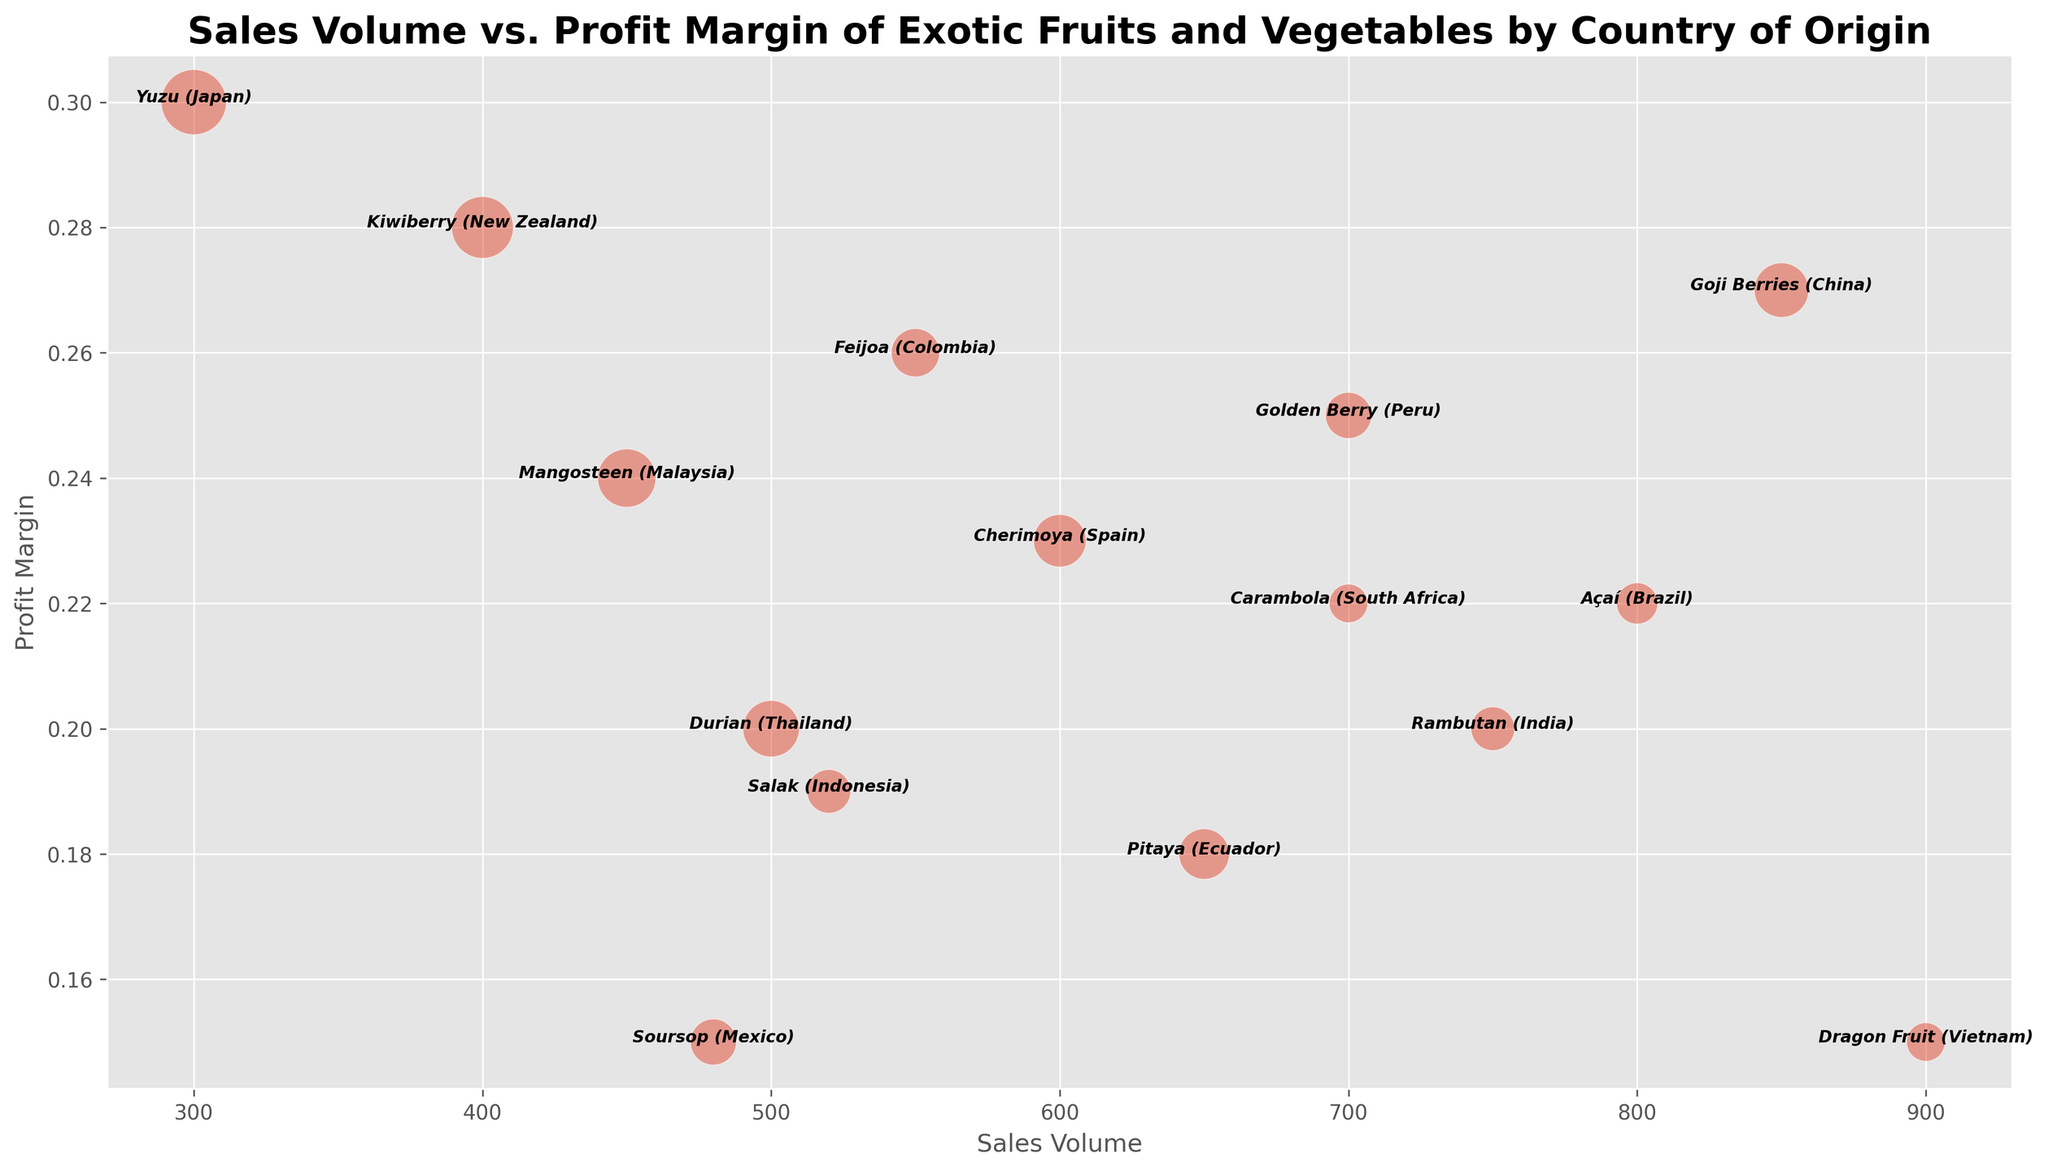What's the country with the highest profit margin for its produce? Look for the bubble situated highest on the profit margin (vertical) axis. The highest point corresponds to Yuzu from Japan with a profit margin of 0.30.
Answer: Japan Which exotic produce has the largest sales volume? Look for the bubble farthest to the right, indicating the highest value on the sales volume (horizontal) axis. Dragon Fruit from Vietnam has the highest sales volume at 900 units.
Answer: Dragon Fruit Which country offers produce with a profit margin less than 0.20 and a sales volume more than 500? Identify bubbles below the 0.20 profit margin line and to the right of the 500 sales volume line. Dragon Fruit from Vietnam (profit margin 0.15) is the answer.
Answer: Vietnam What are the top three countries in terms of sales volume? Sort bubbles by their position on the sales volume (horizontal) axis. The top three bubbles are Dragon Fruit (Vietnam, 900), Goji Berries (China, 850), and Açaí (Brazil, 800).
Answer: Vietnam, China, Brazil How does the profit margin of Rambutan compare to that of Pitaya? Find the bubbles for Rambutan and Pitaya and compare their positions on the profit margin axis. Rambutan has a profit margin of 0.20, whereas Pitaya has a profit margin of 0.18.
Answer: Higher Which produce has the highest average price and what is its sales volume? Find the largest bubble, which indicates the highest average price. Yuzu from Japan, with the largest bubble size, has a sales volume of 300.
Answer: Yuzu, 300 What is the combined sales volume for Goji Berries and Feijoa? Locate the bubbles for Goji Berries and Feijoa and sum their sales volumes: 850 (Goji Berries) + 550 (Feijoa) = 1400.
Answer: 1400 How much more profit margin does Yuzu have compared to Carambola? Subtract the profit margin of Carambola from that of Yuzu: 0.30 (Yuzu) - 0.22 (Carambola) = 0.08.
Answer: 0.08 Which produce from South America has the highest profit margin? Identify the bubbles representing South American countries and compare their positions on the profit margin axis. Golden Berry from Peru has the highest profit margin among South American produce at 0.25.
Answer: Golden Berry Is there any produce with a profit margin of exactly 0.15? Look for bubbles positioned exactly at the 0.15 mark on the profit margin axis. Dragon Fruit from Vietnam and Soursop from Mexico have a profit margin of 0.15.
Answer: Yes, Dragon Fruit and Soursop 